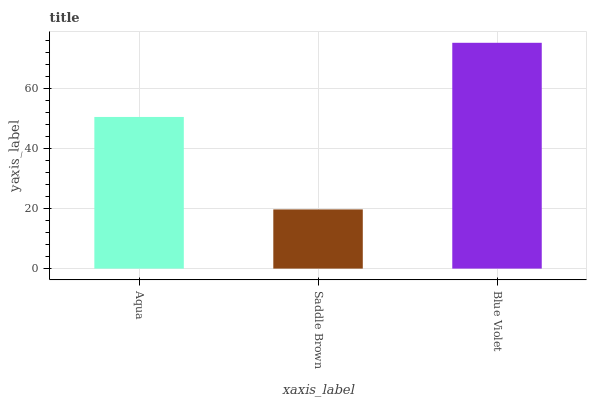Is Saddle Brown the minimum?
Answer yes or no. Yes. Is Blue Violet the maximum?
Answer yes or no. Yes. Is Blue Violet the minimum?
Answer yes or no. No. Is Saddle Brown the maximum?
Answer yes or no. No. Is Blue Violet greater than Saddle Brown?
Answer yes or no. Yes. Is Saddle Brown less than Blue Violet?
Answer yes or no. Yes. Is Saddle Brown greater than Blue Violet?
Answer yes or no. No. Is Blue Violet less than Saddle Brown?
Answer yes or no. No. Is Aqua the high median?
Answer yes or no. Yes. Is Aqua the low median?
Answer yes or no. Yes. Is Blue Violet the high median?
Answer yes or no. No. Is Blue Violet the low median?
Answer yes or no. No. 